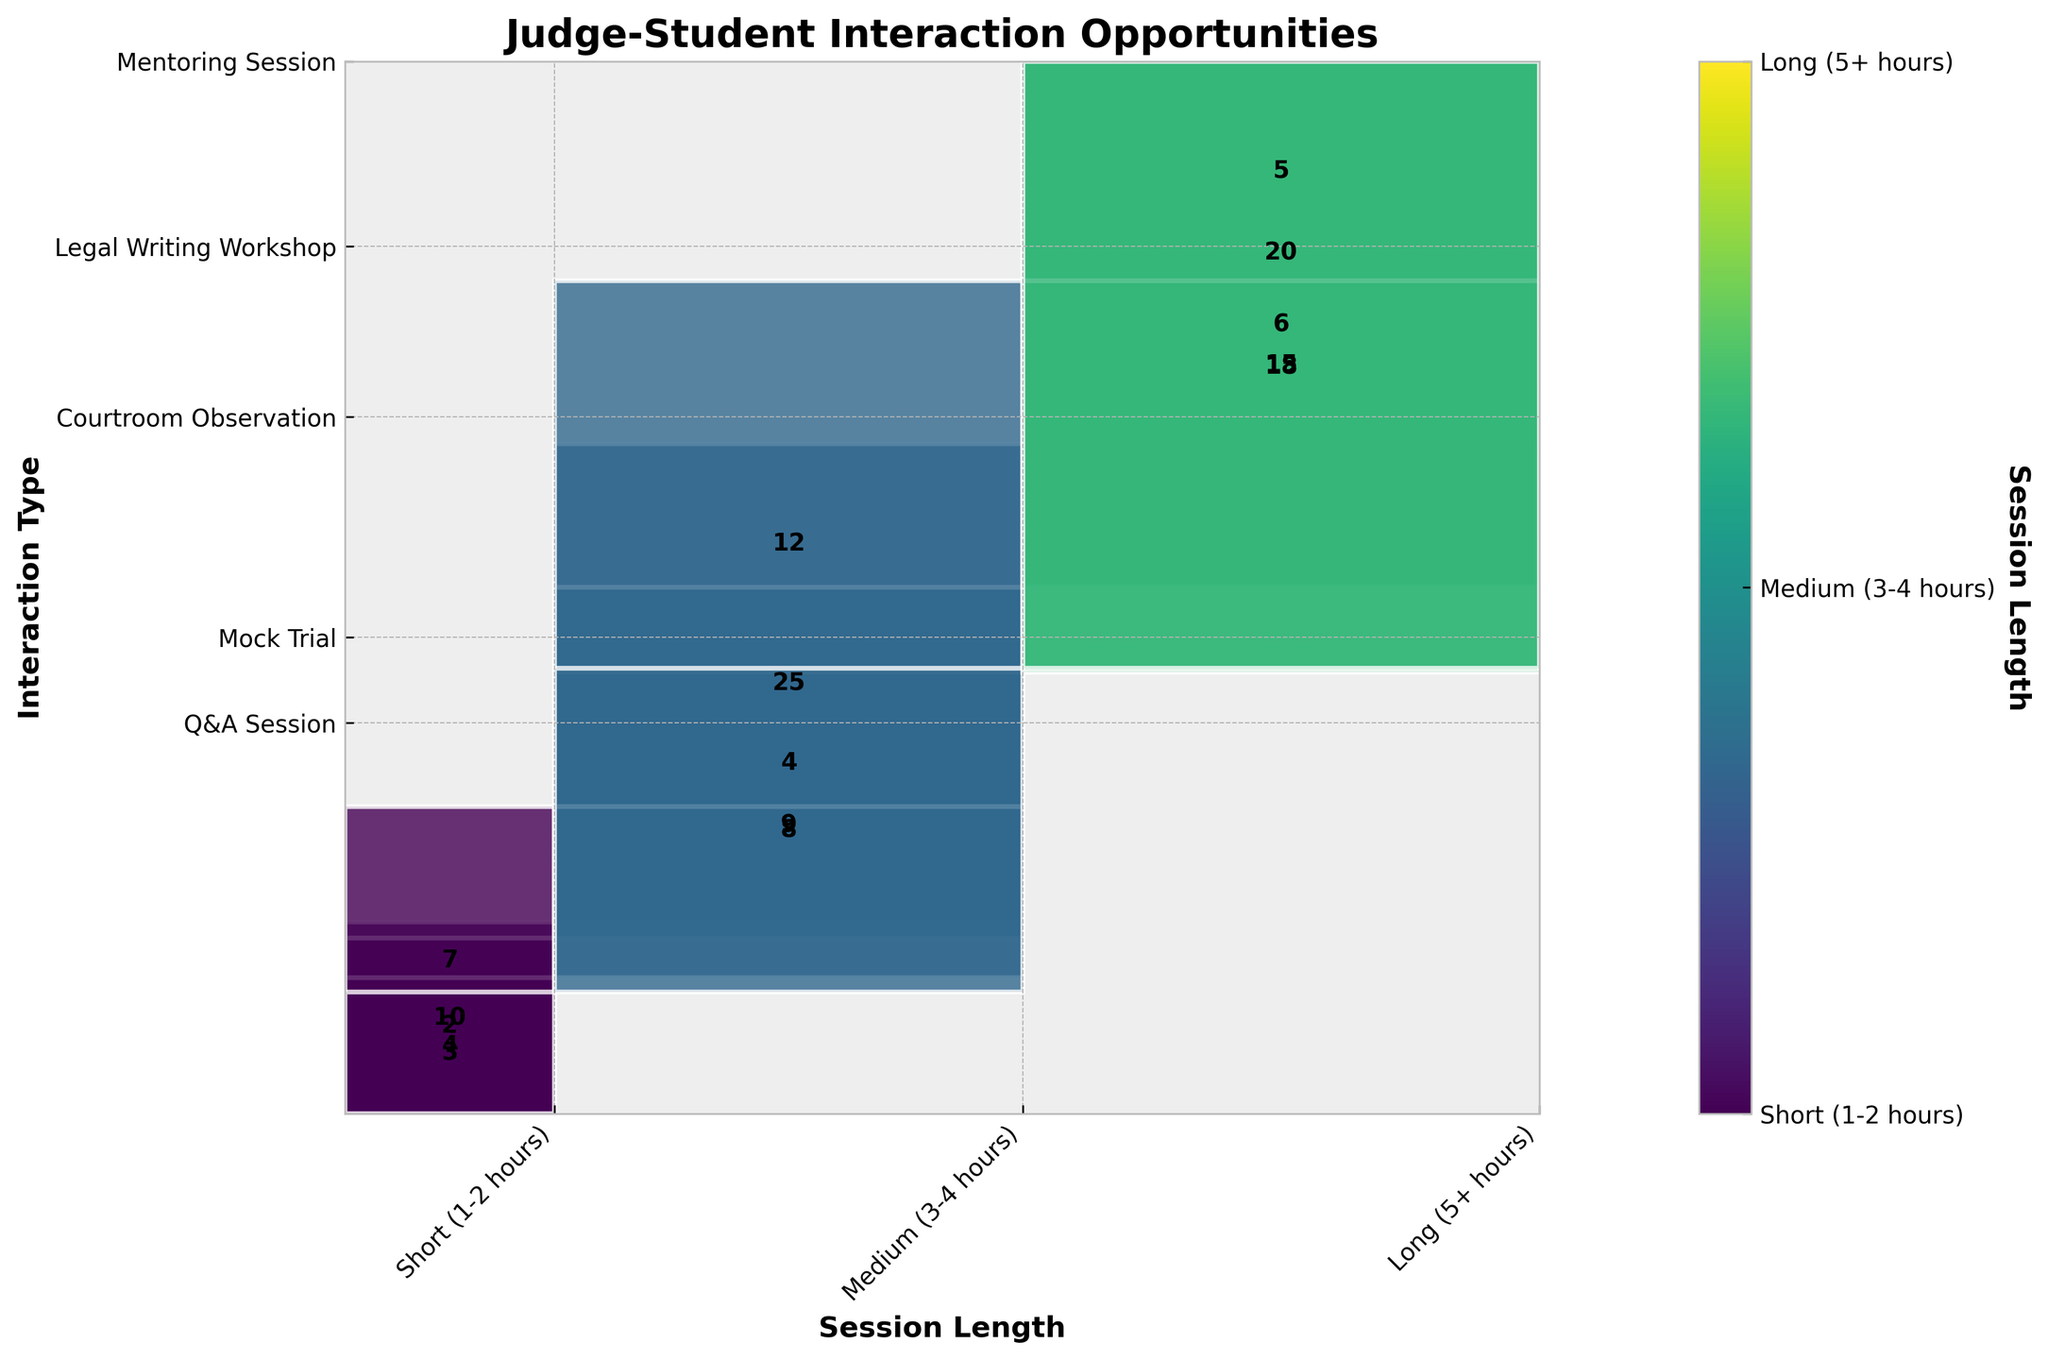What is the title of the figure? The title is usually prominently displayed at the top of the figure, providing a summary or main subject being visualized. By looking at the top of the figure, we can identify the title as "Judge-Student Interaction Opportunities".
Answer: Judge-Student Interaction Opportunities How many short (1-2 hours) Q&A Sessions are there? Locate the "Q&A Session" row on the y-axis and then move to the column corresponding to "Short (1-2 hours)" on the x-axis. The intersection should display the frequency, which is 15.
Answer: 15 Which session length has the highest frequency for Mock Trial? Find the "Mock Trial" row on the y-axis and compare the heights of rectangles in the "Short (1-2 hours)", "Medium (3-4 hours)", and "Long (5+ hours)" columns. The "Medium (3-4 hours)" session length has the largest rectangle, indicating the highest frequency, which is 12.
Answer: Medium (3-4 hours) What is the total frequency of Legal Writing Workshops across all session lengths? Locate the row for "Legal Writing Workshop" and sum the frequencies of short, medium, and long sessions: 6 (short) + 4 (medium) + 2 (long) = 12.
Answer: 12 For which interaction type is there the biggest difference in frequency between short and long sessions? Calculate the absolute difference in frequency between short and long sessions for each interaction type:
- Q&A Session: 15 (short) - 3 (long) = 12
- Mock Trial: 5 (short) - 7 (long) = 2
- Courtroom Observation: 20 (short) - 10 (long) = 10
- Legal Writing Workshop: 6 (short) - 2 (long) = 4
- Mentoring Session: 18 (short) - 4 (long) = 14
The biggest difference is for "Mentoring Session", which is 14.
Answer: Mentoring Session What proportion of Courtroom Observations occur during medium-length sessions? Find the "Courtroom Observation" row and focus on the "Medium (3-4 hours)" column. The frequency for medium sessions is 25. Sum the frequencies for all session lengths: 20 (short) + 25 (medium) + 10 (long) = 55. The proportion is then calculated as 25/55 ≈ 0.45, or 45%.
Answer: 45% Which session length has the lowest overall frequency for all interaction types combined? Sum the frequencies for each session length across all interaction types:
- Short (1-2 hours): 15 + 5 + 20 + 6 + 18 = 64
- Medium (3-4 hours): 8 + 12 + 25 + 4 + 9 = 58
- Long (5+ hours): 3 + 7 + 10 + 2 + 4 = 26
The "Long (5+ hours)" session length has the lowest total frequency, which is 26.
Answer: Long (5+ hours) How does the frequency of short (1-2 hours) sessions for Mentoring Sessions compare to Q&A Sessions? Compare the frequencies of short sessions for both interaction types:
- Q&A Session (short): 15
- Mentoring Session (short): 18
The frequency of Mentoring Sessions is higher than Q&A Sessions for short (1-2 hours) sessions.
Answer: Mentoring Sessions are higher What is the most common interaction type overall, and how many sessions does it have? Sum the frequencies across all session lengths for each interaction type and identify the highest:
- Q&A Session: 15 + 8 + 3 = 26
- Mock Trial: 5 + 12 + 7 = 24
- Courtroom Observation: 20 + 25 + 10 = 55
- Legal Writing Workshop: 6 + 4 + 2 = 12
- Mentoring Session: 18 + 9 + 4 = 31
The most common interaction type is "Courtroom Observation" with a total of 55 sessions.
Answer: Courtroom Observation, 55 